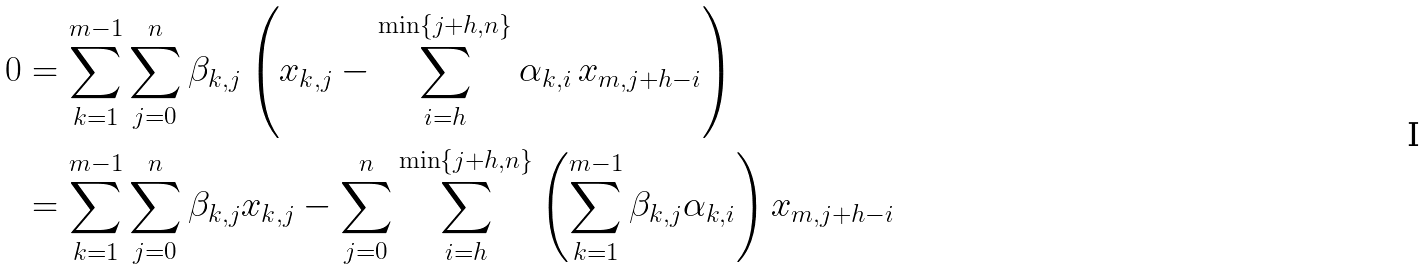<formula> <loc_0><loc_0><loc_500><loc_500>0 & = \sum _ { k = 1 } ^ { m - 1 } \sum _ { j = 0 } ^ { n } \beta _ { k , j } \left ( x _ { k , j } - \sum _ { i = h } ^ { \min \{ j + h , n \} } \alpha _ { k , i } \, x _ { m , j + h - i } \right ) \\ & = \sum _ { k = 1 } ^ { m - 1 } \sum _ { j = 0 } ^ { n } \beta _ { k , j } x _ { k , j } - \sum _ { j = 0 } ^ { n } \sum _ { i = h } ^ { \min \{ j + h , n \} } \left ( \sum _ { k = 1 } ^ { m - 1 } \beta _ { k , j } \alpha _ { k , i } \right ) x _ { m , j + h - i }</formula> 